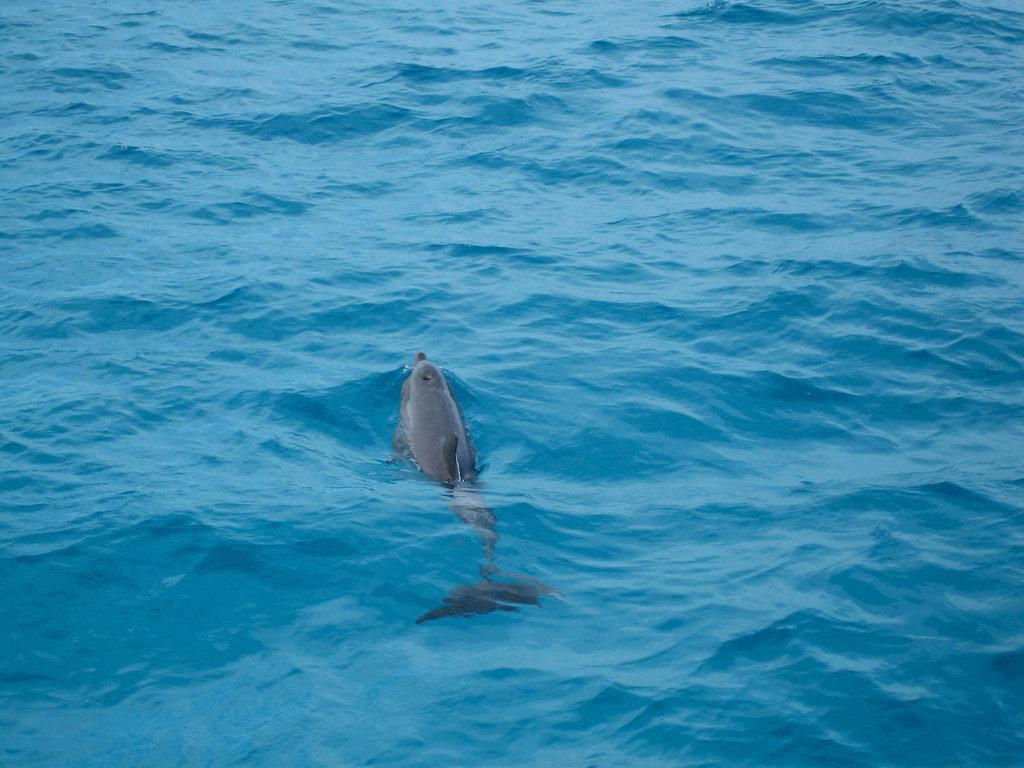Can you describe this image briefly? In this picture we observe the dolphin swimming in the water. 